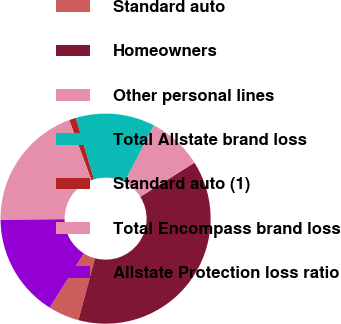<chart> <loc_0><loc_0><loc_500><loc_500><pie_chart><fcel>Standard auto<fcel>Homeowners<fcel>Other personal lines<fcel>Total Allstate brand loss<fcel>Standard auto (1)<fcel>Total Encompass brand loss<fcel>Allstate Protection loss ratio<nl><fcel>4.76%<fcel>38.11%<fcel>8.46%<fcel>12.17%<fcel>1.05%<fcel>19.58%<fcel>15.87%<nl></chart> 